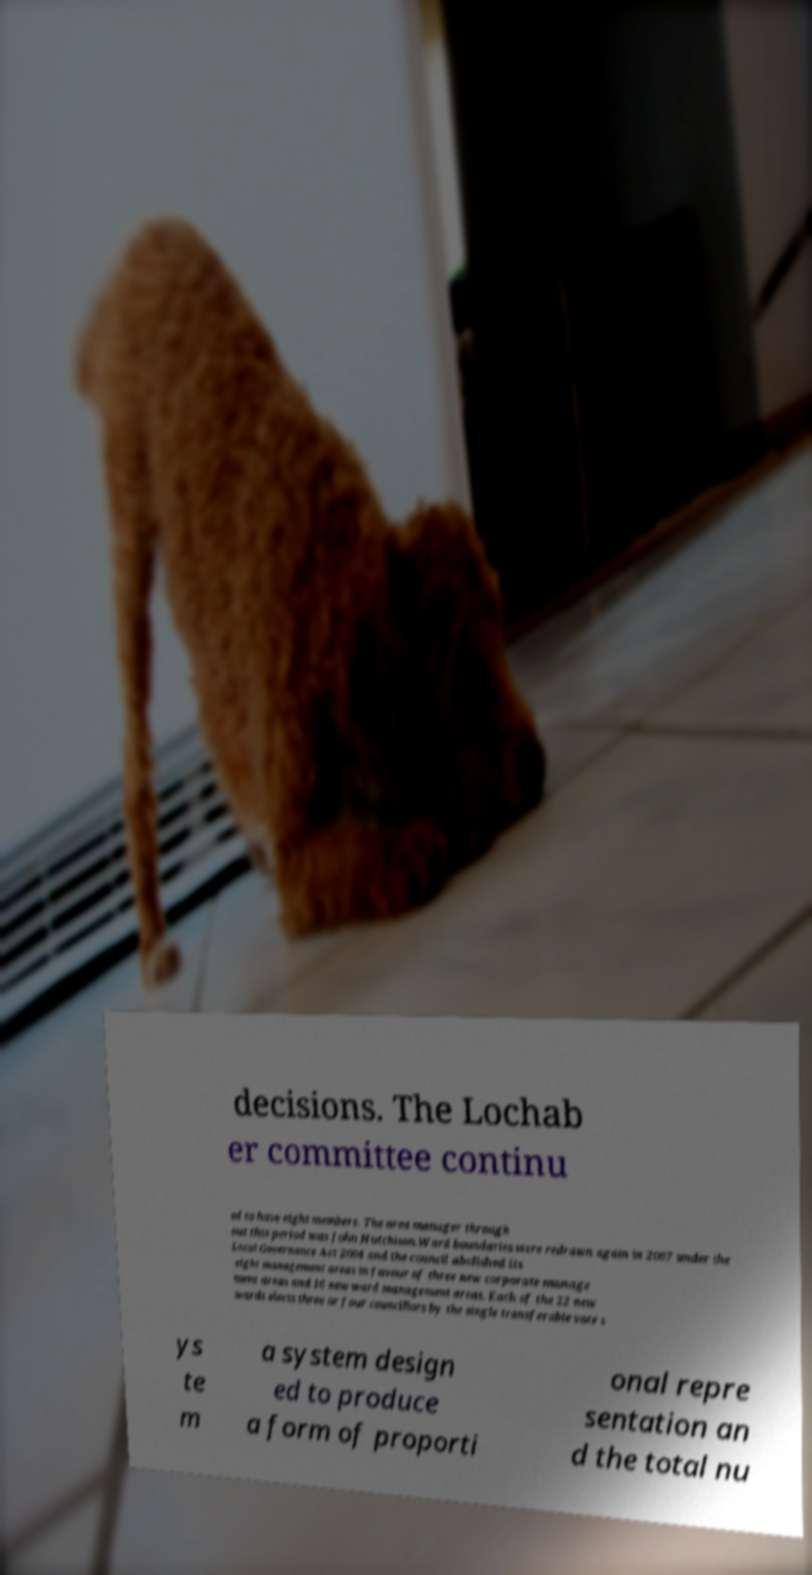For documentation purposes, I need the text within this image transcribed. Could you provide that? decisions. The Lochab er committee continu ed to have eight members. The area manager through out this period was John Hutchison.Ward boundaries were redrawn again in 2007 under the Local Governance Act 2004 and the council abolished its eight management areas in favour of three new corporate manage ment areas and 16 new ward management areas. Each of the 22 new wards elects three or four councillors by the single transferable vote s ys te m a system design ed to produce a form of proporti onal repre sentation an d the total nu 